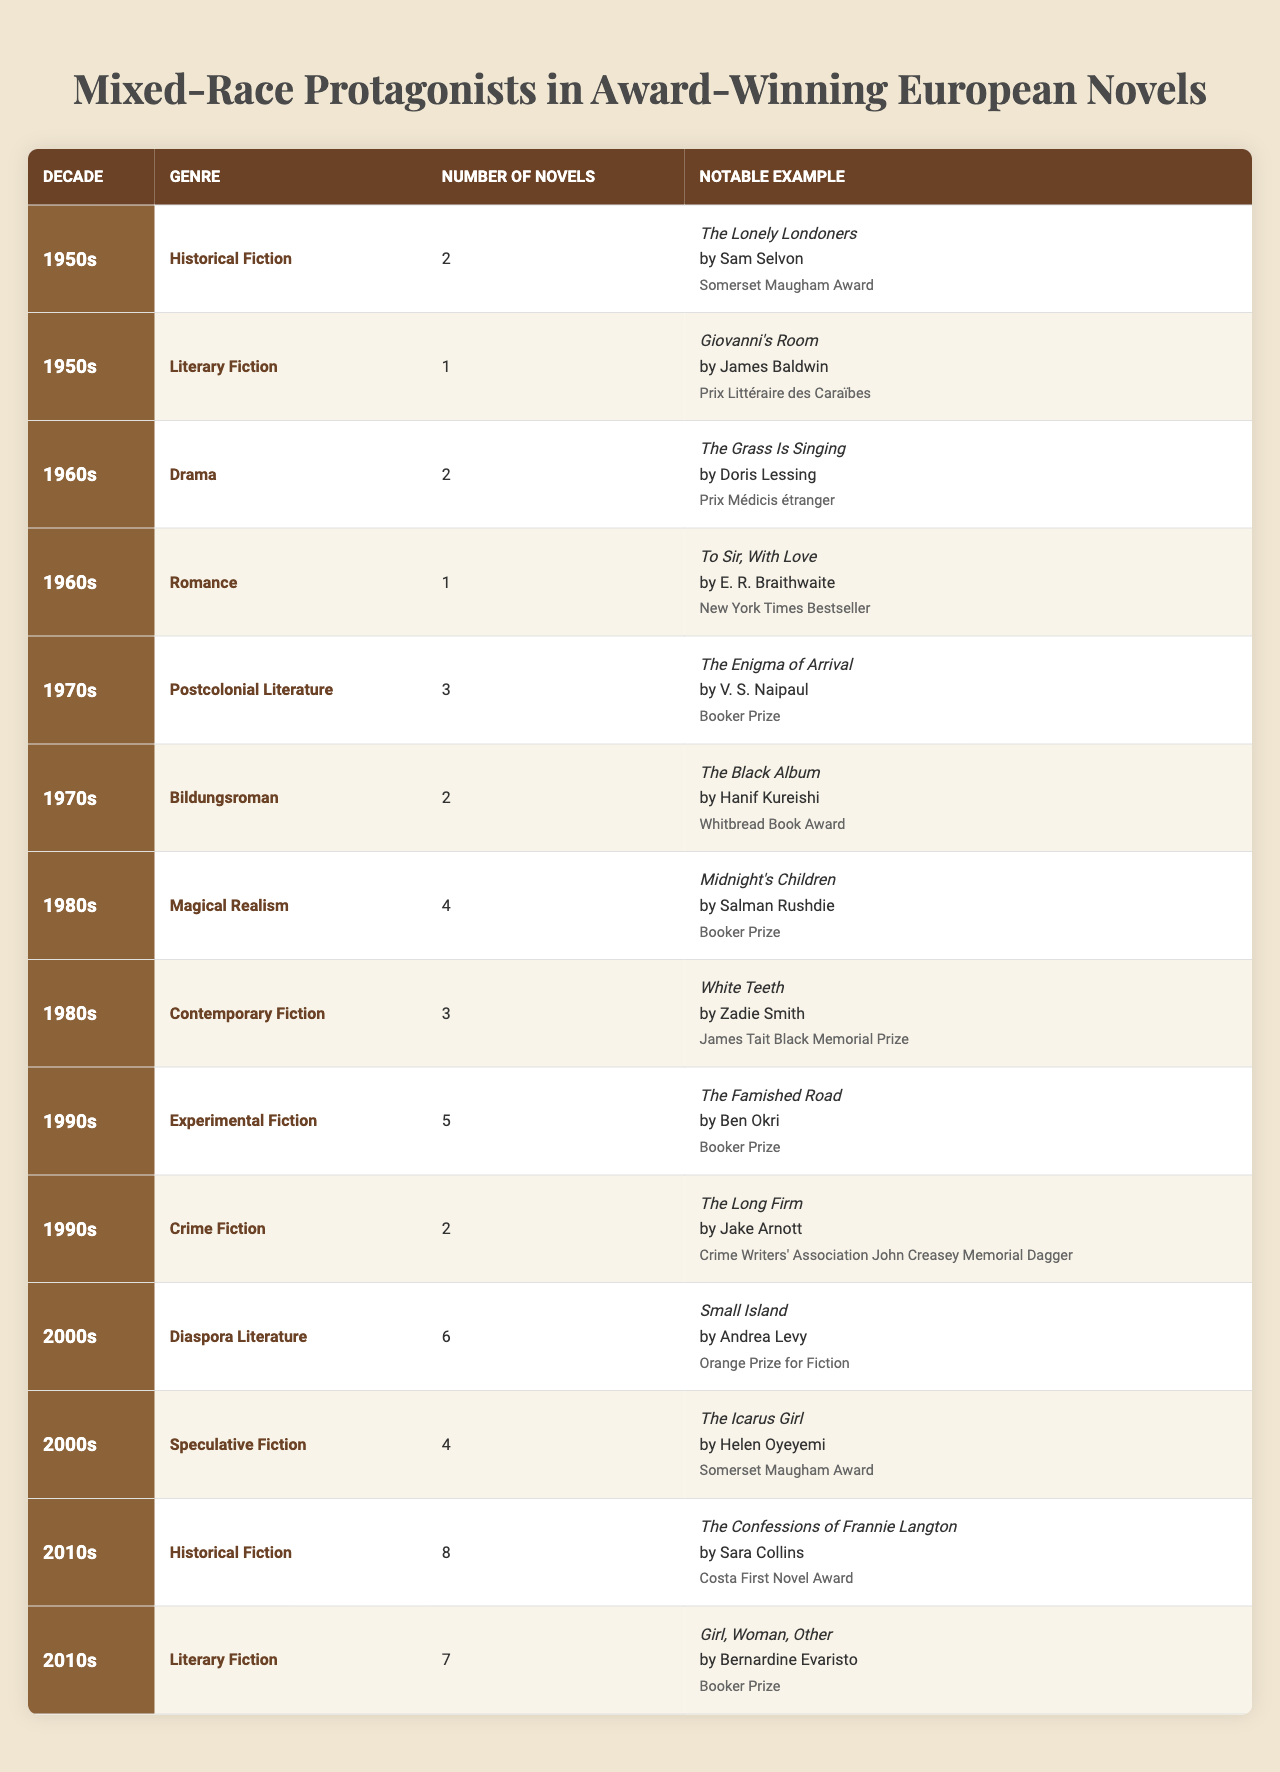What genre had the most novels featuring mixed-race protagonists in the 2010s? In the 2010s, the genre with the most novels featuring mixed-race protagonists is Historical Fiction, with 8 novels listed.
Answer: Historical Fiction How many novels featuring mixed-race protagonists were published in the 1980s? The 1980s saw a total of 7 novels (4 in Magical Realism and 3 in Contemporary Fiction) featuring mixed-race protagonists.
Answer: 7 Did any novels featuring mixed-race protagonists win awards in the 1960s? Yes, "The Grass Is Singing" by Doris Lessing, which won the Prix Médicis étranger, is a notable example from that decade.
Answer: Yes What is the total number of novels featuring mixed-race protagonists from the 1970s? The 1970s had 5 novels in total (3 in Postcolonial Literature and 2 in Bildungsroman). Summing these gives 3 + 2 = 5.
Answer: 5 Which decade had the fewest novels featuring mixed-race protagonists? The 1950s had the fewest novels with a total of 3 (2 in Historical Fiction and 1 in Literary Fiction).
Answer: 1950s How many novels featuring mixed-race protagonists won the Booker Prize? There are 3 novels that won the Booker Prize: "The Enigma of Arrival" (1970s), "Midnight's Children" (1980s), and "The Famished Road" (1990s), making the total count 3.
Answer: 3 Which genre had a higher count of novels featuring mixed-race protagonists in the 2000s: Diaspora Literature or Speculative Fiction? Diaspora Literature had 6 novels, while Speculative Fiction had 4 novels; thus, Diaspora Literature had a higher count.
Answer: Diaspora Literature During which decade was the highest number of novels featuring mixed-race protagonists published? The 2010s had the highest total with 15 novels (8 in Historical Fiction and 7 in Literary Fiction), making it the decade with the most.
Answer: 2010s Which author won an award for a notable work in the 1990s? Ben Okri won the Booker Prize for "The Famished Road," a notable work from the 1990s listed in the table.
Answer: Ben Okri How does the number of novels in the 2000s compare to the 1990s? The 2000s had 10 novels (6 in Diaspora Literature and 4 in Speculative Fiction), while the 1990s had 7 novels (5 in Experimental Fiction and 2 in Crime Fiction); thus, the 2000s had 3 more novels than the 1990s.
Answer: 3 more novels in the 2000s 